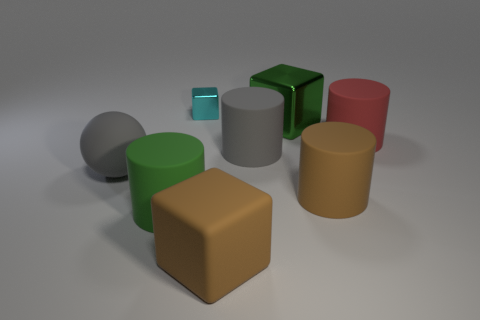There is a metal object that is in front of the small cyan metal object; is it the same color as the small shiny thing?
Keep it short and to the point. No. There is another rubber object that is the same shape as the cyan object; what size is it?
Your answer should be very brief. Large. Is the small thing the same color as the large rubber block?
Offer a very short reply. No. What color is the big object that is to the left of the brown rubber cylinder and behind the large gray cylinder?
Offer a very short reply. Green. How many objects are either large things on the left side of the big brown rubber block or small metal blocks?
Give a very brief answer. 3. What is the color of the small shiny thing that is the same shape as the large metal thing?
Keep it short and to the point. Cyan. Does the small thing have the same shape as the green thing that is left of the gray cylinder?
Make the answer very short. No. How many objects are either large objects in front of the big gray cylinder or objects that are behind the brown cube?
Make the answer very short. 8. Are there fewer small cyan things that are right of the gray matte cylinder than blue metal things?
Your answer should be very brief. No. Are the gray cylinder and the big cylinder that is to the left of the small cyan metallic block made of the same material?
Your answer should be very brief. Yes. 